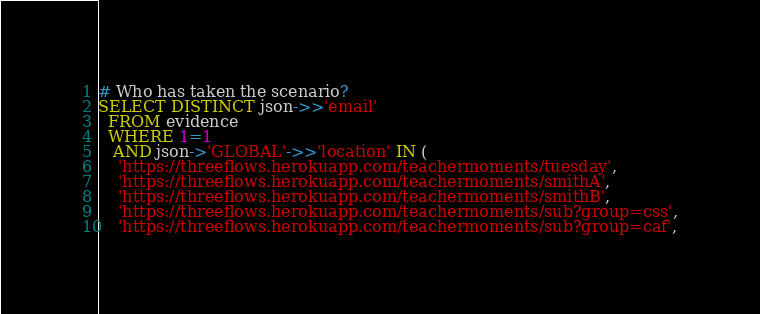<code> <loc_0><loc_0><loc_500><loc_500><_SQL_># Who has taken the scenario?
SELECT DISTINCT json->>'email'
  FROM evidence
  WHERE 1=1
   AND json->'GLOBAL'->>'location' IN (
    'https://threeflows.herokuapp.com/teachermoments/tuesday',
    'https://threeflows.herokuapp.com/teachermoments/smithA',
    'https://threeflows.herokuapp.com/teachermoments/smithB',
    'https://threeflows.herokuapp.com/teachermoments/sub?group=css',
    'https://threeflows.herokuapp.com/teachermoments/sub?group=caf',</code> 